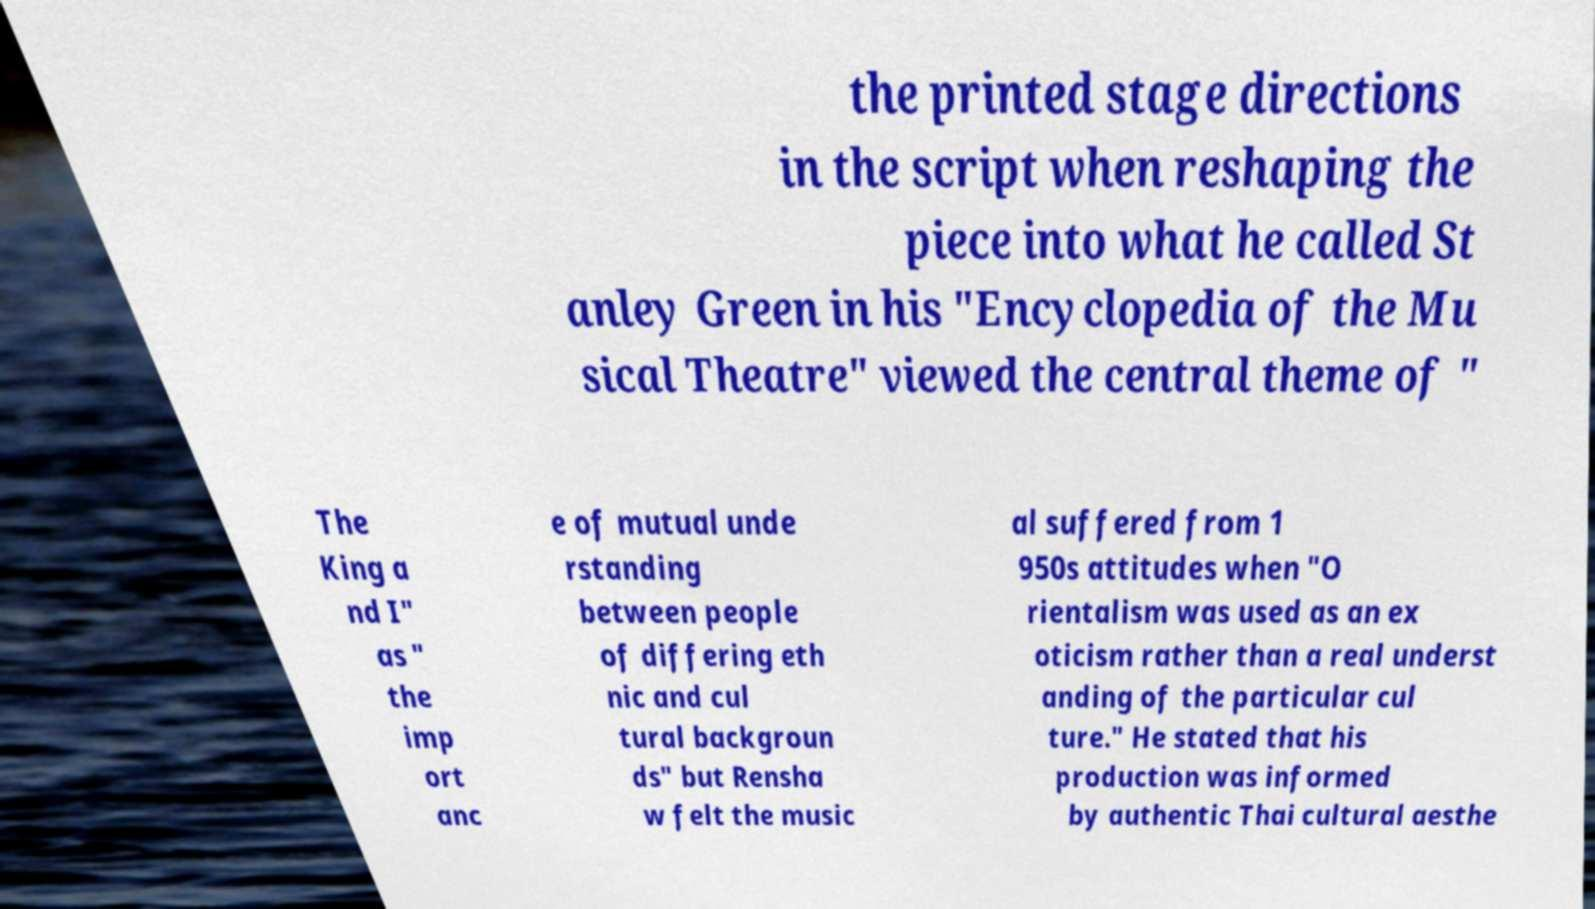I need the written content from this picture converted into text. Can you do that? the printed stage directions in the script when reshaping the piece into what he called St anley Green in his "Encyclopedia of the Mu sical Theatre" viewed the central theme of " The King a nd I" as " the imp ort anc e of mutual unde rstanding between people of differing eth nic and cul tural backgroun ds" but Rensha w felt the music al suffered from 1 950s attitudes when "O rientalism was used as an ex oticism rather than a real underst anding of the particular cul ture." He stated that his production was informed by authentic Thai cultural aesthe 